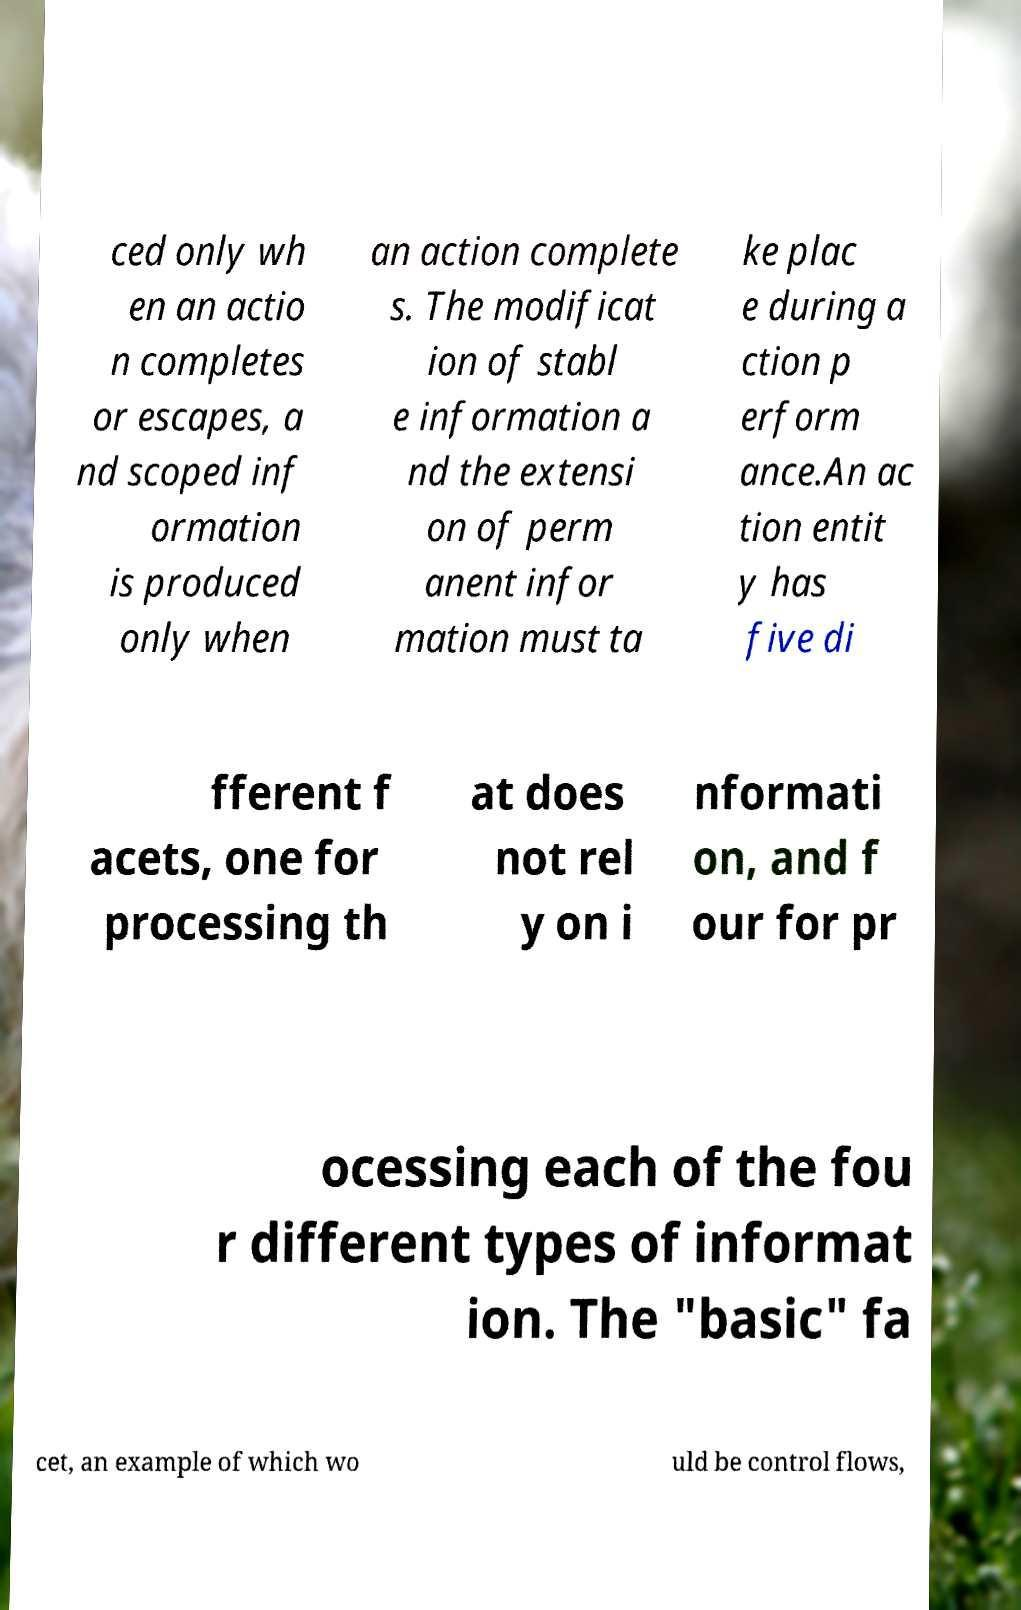Please read and relay the text visible in this image. What does it say? ced only wh en an actio n completes or escapes, a nd scoped inf ormation is produced only when an action complete s. The modificat ion of stabl e information a nd the extensi on of perm anent infor mation must ta ke plac e during a ction p erform ance.An ac tion entit y has five di fferent f acets, one for processing th at does not rel y on i nformati on, and f our for pr ocessing each of the fou r different types of informat ion. The "basic" fa cet, an example of which wo uld be control flows, 